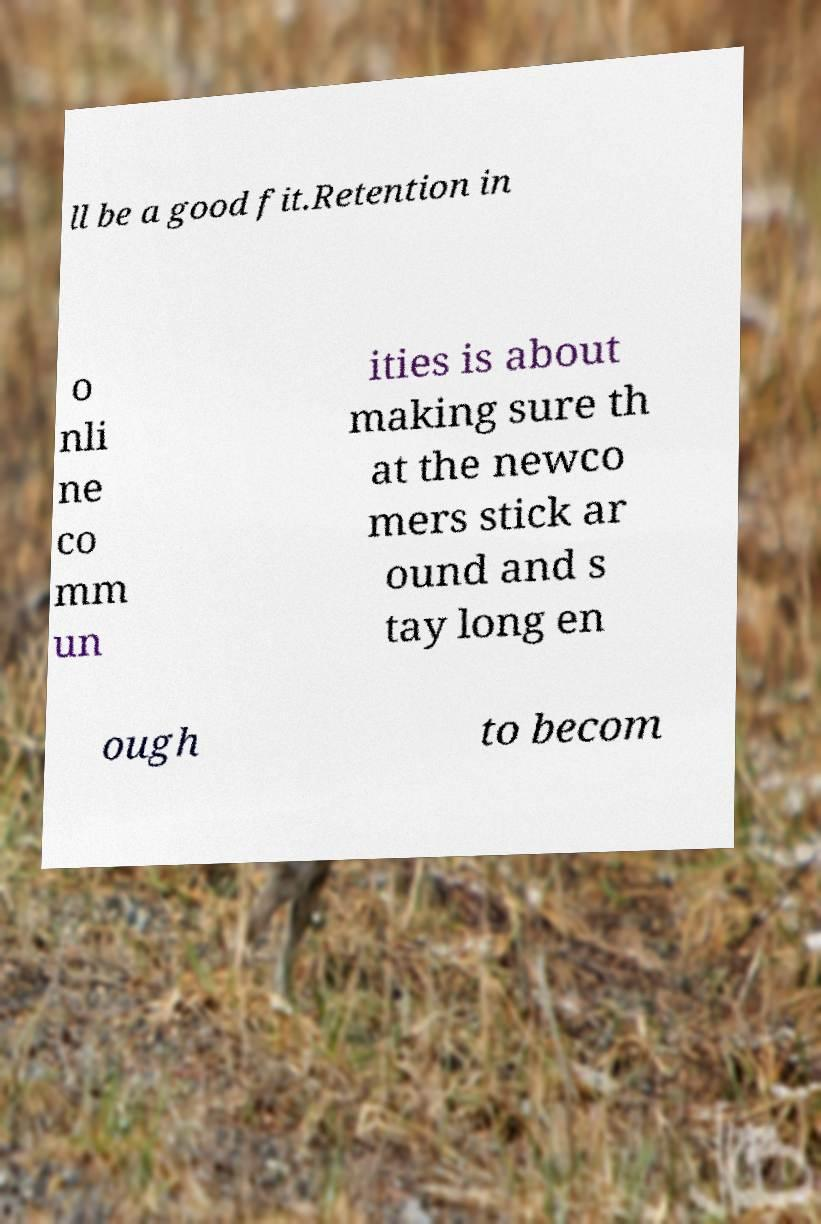Can you accurately transcribe the text from the provided image for me? ll be a good fit.Retention in o nli ne co mm un ities is about making sure th at the newco mers stick ar ound and s tay long en ough to becom 